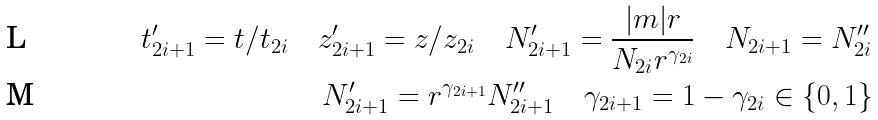<formula> <loc_0><loc_0><loc_500><loc_500>t _ { 2 i + 1 } ^ { \prime } = t / t _ { 2 i } \quad z _ { 2 i + 1 } ^ { \prime } = z / z _ { 2 i } \quad N _ { 2 i + 1 } ^ { \prime } = \frac { | m | r } { N _ { 2 i } r ^ { \gamma _ { 2 i } } } \quad N _ { 2 i + 1 } = N _ { 2 i } ^ { \prime \prime } \\ N _ { 2 i + 1 } ^ { \prime } = r ^ { \gamma _ { 2 i + 1 } } N _ { 2 i + 1 } ^ { \prime \prime } \quad \gamma _ { 2 i + 1 } = 1 - \gamma _ { 2 i } \in \{ 0 , 1 \}</formula> 